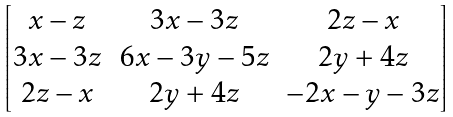<formula> <loc_0><loc_0><loc_500><loc_500>\begin{bmatrix} x - z & 3 x - 3 z & 2 z - x \\ 3 x - 3 z & 6 x - 3 y - 5 z & 2 y + 4 z \\ 2 z - x & 2 y + 4 z & - 2 x - y - 3 z \end{bmatrix}</formula> 